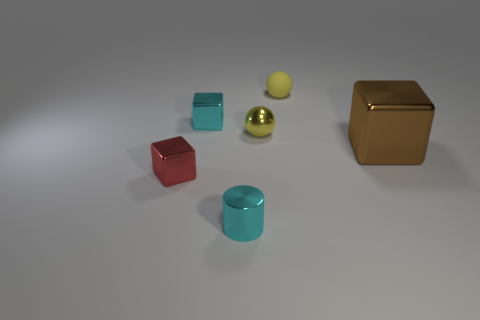Are there more tiny cyan shiny cylinders than big gray metal objects?
Your response must be concise. Yes. How many other things are the same color as the shiny cylinder?
Give a very brief answer. 1. What number of things are either tiny rubber things or big brown shiny blocks?
Keep it short and to the point. 2. There is a object in front of the red object; is it the same shape as the red thing?
Your answer should be compact. No. There is a small cube that is behind the block to the right of the small cyan metal cylinder; what is its color?
Your response must be concise. Cyan. Are there fewer large brown objects than large blue metallic spheres?
Offer a terse response. No. Is there another small cylinder that has the same material as the tiny cylinder?
Your response must be concise. No. There is a tiny red shiny object; does it have the same shape as the metallic thing behind the small yellow metal thing?
Ensure brevity in your answer.  Yes. There is a rubber thing; are there any cubes to the left of it?
Give a very brief answer. Yes. How many other objects have the same shape as the small yellow shiny thing?
Your answer should be compact. 1. 